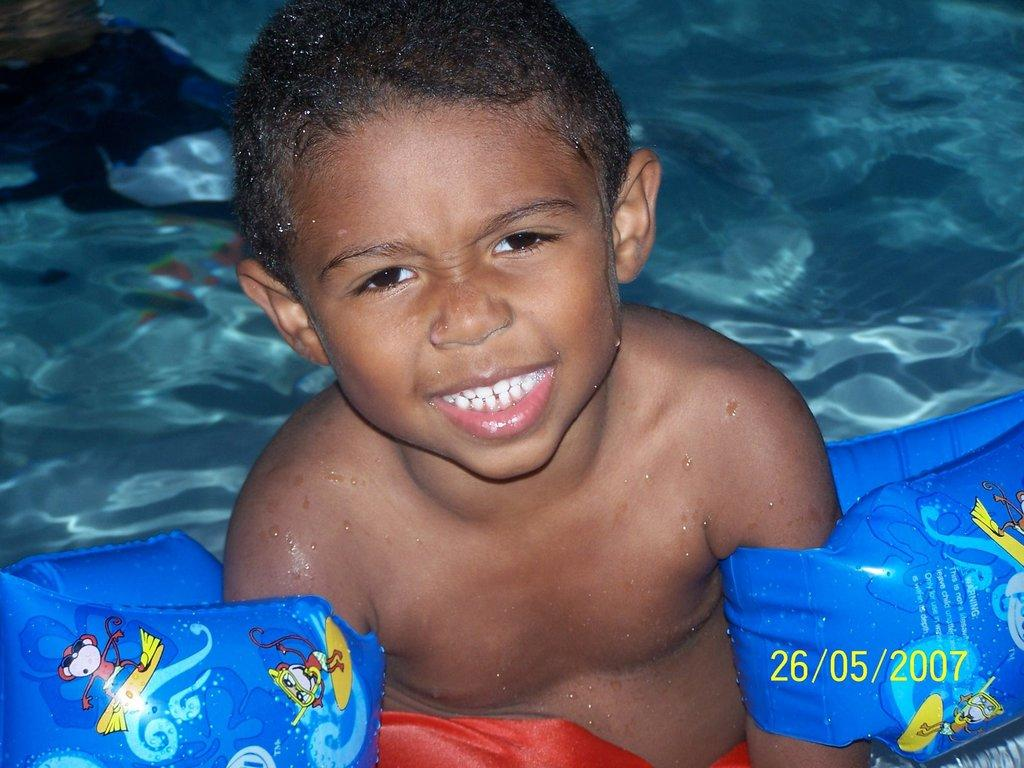Who is the main subject in the image? There is a boy in the image. What is the boy doing in the image? The boy is swimming in the water. What type of wrench is the boy using while swimming in the image? There is no wrench present in the image; the boy is simply swimming in the water. 